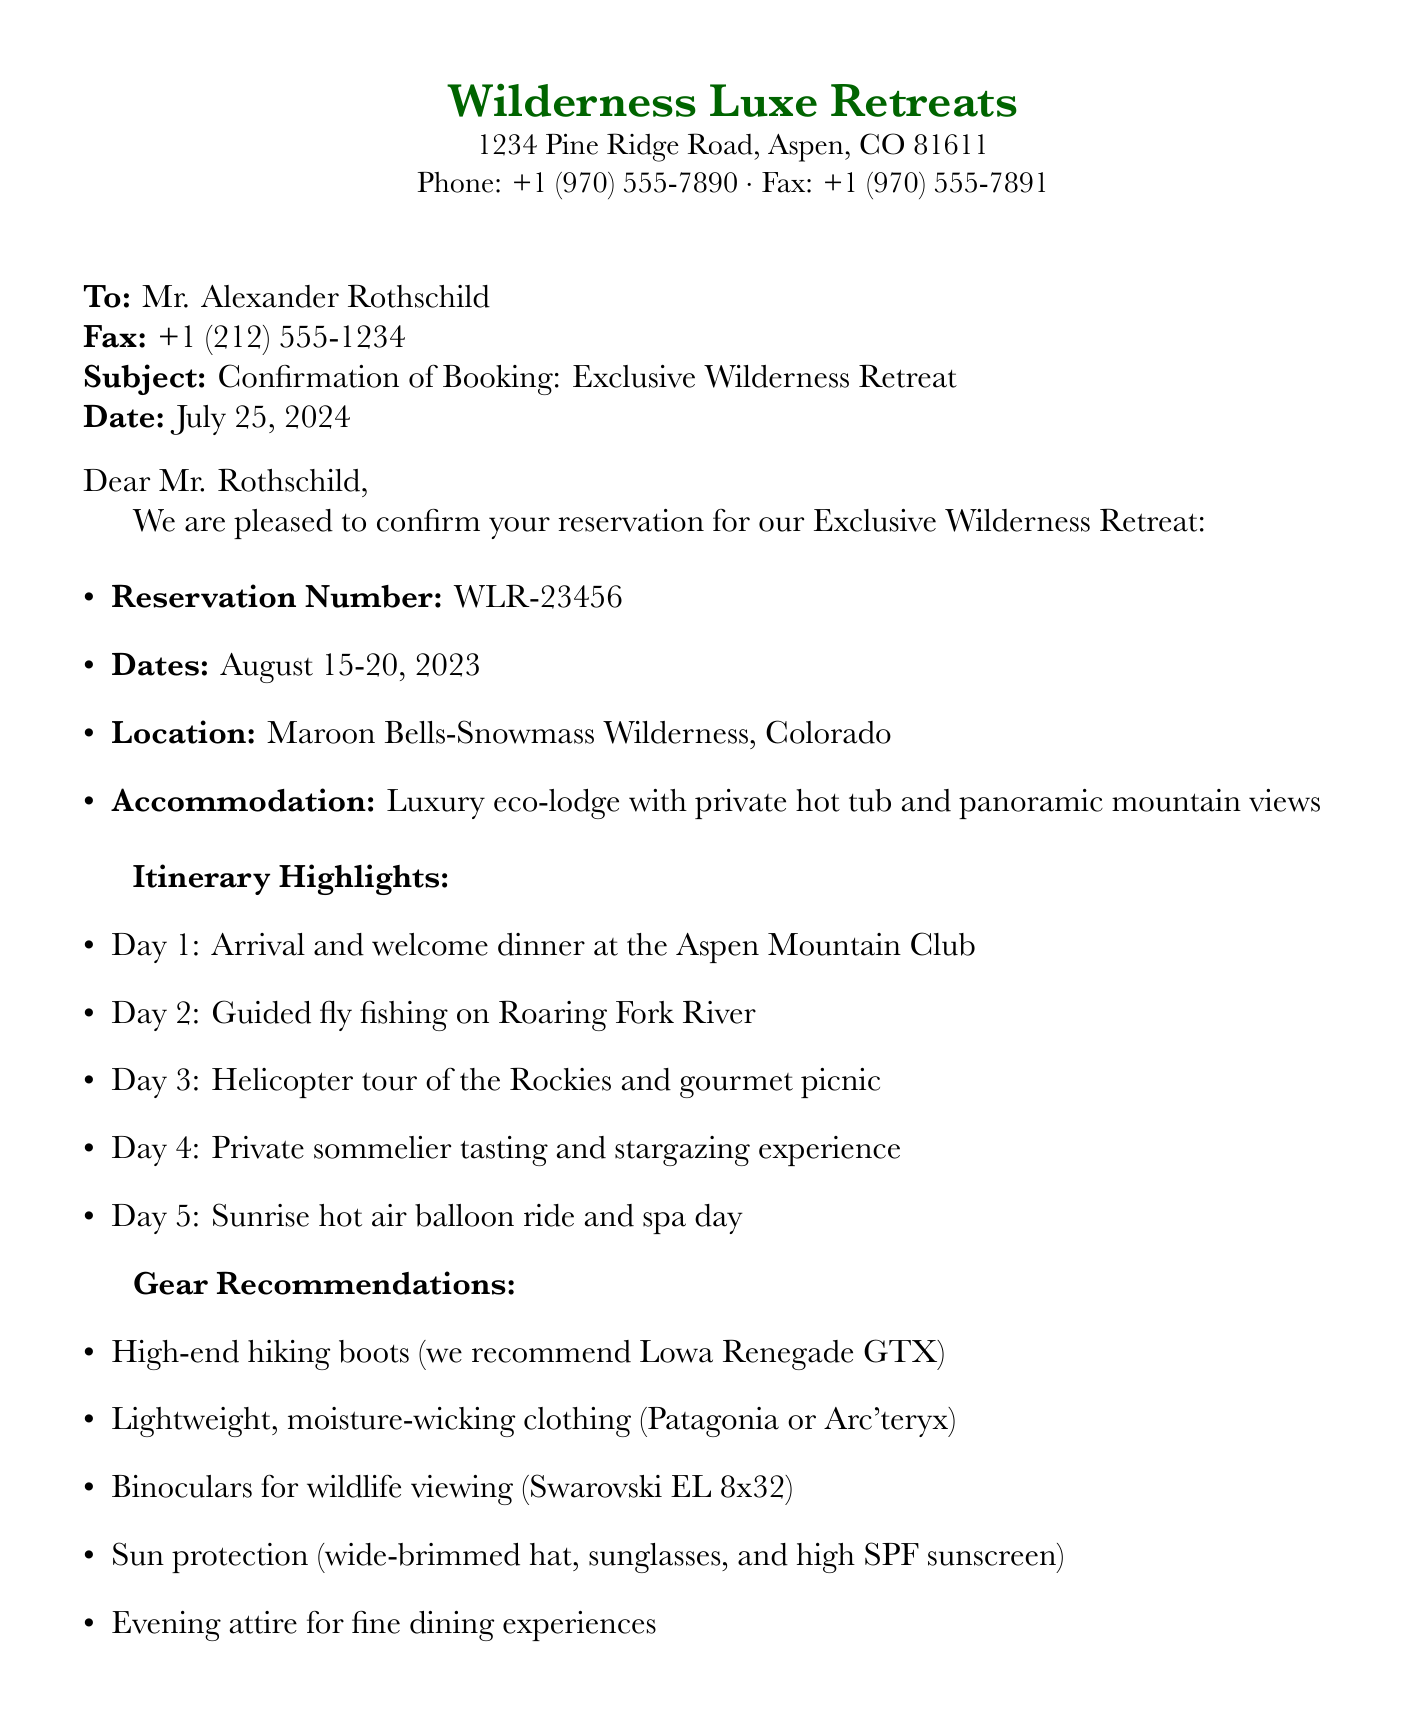What is the reservation number? The reservation number is explicitly stated in the document as WLR-23456.
Answer: WLR-23456 What are the dates of the retreat? The document specifies the dates as August 15-20, 2023.
Answer: August 15-20, 2023 What location is the retreat held at? The document mentions the location as Maroon Bells-Snowmass Wilderness, Colorado.
Answer: Maroon Bells-Snowmass Wilderness, Colorado What is included in the total payment? The document states that the full payment of $15,000 has been received via wire transfer for the booking.
Answer: $15,000 What activity is scheduled for Day 3? The document lists a helicopter tour of the Rockies and a gourmet picnic as the activity for Day 3.
Answer: Helicopter tour of the Rockies and gourmet picnic What is one recommended item for sun protection? The document suggests a wide-brimmed hat as part of the sun protection gear.
Answer: Wide-brimmed hat Which luxury vehicle is included with the booking? The document specifies that a Range Rover Sport is included in the luxury vehicle rental.
Answer: Range Rover Sport How many days is the retreat? The retreat lasts for a total of five days, as detailed in the itinerary.
Answer: Five days 